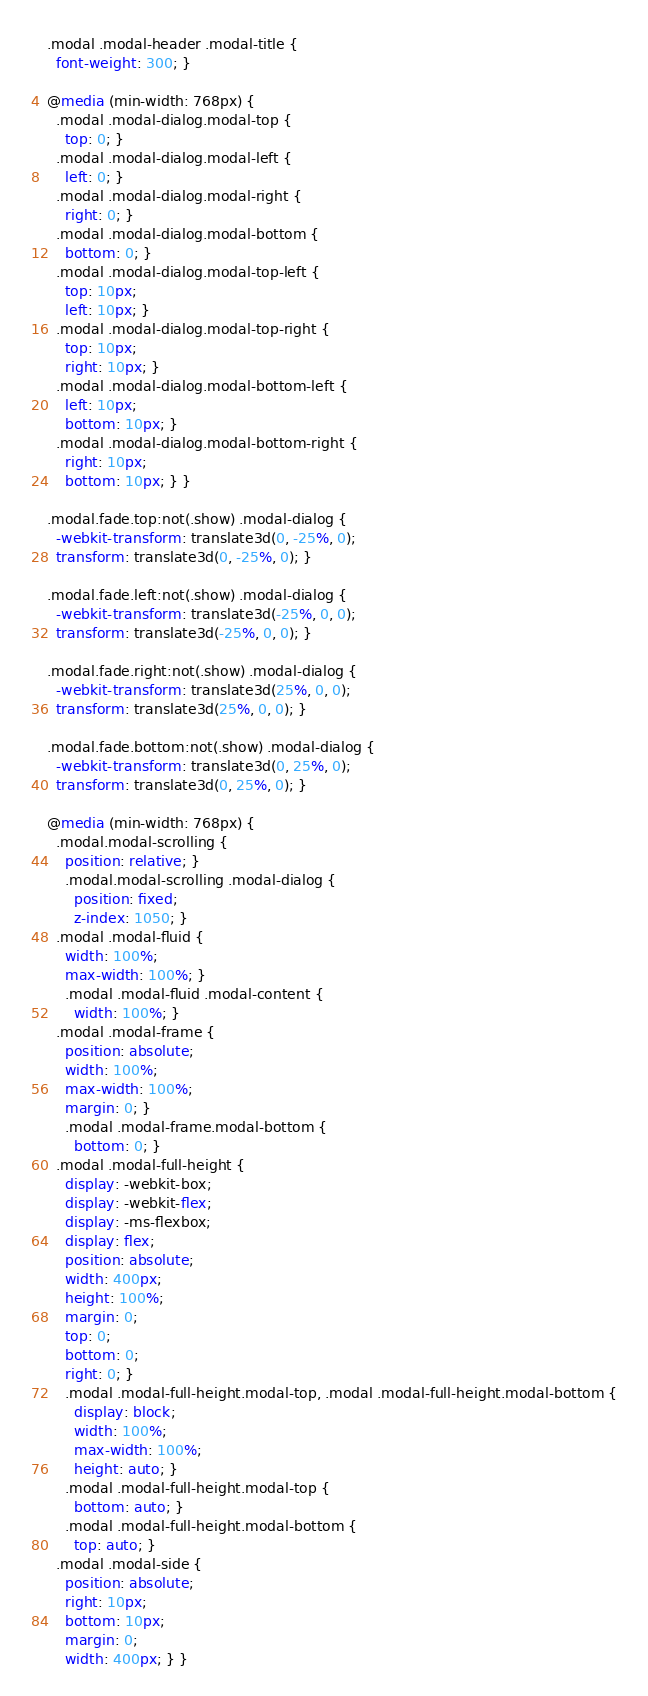Convert code to text. <code><loc_0><loc_0><loc_500><loc_500><_CSS_>
.modal .modal-header .modal-title {
  font-weight: 300; }

@media (min-width: 768px) {
  .modal .modal-dialog.modal-top {
    top: 0; }
  .modal .modal-dialog.modal-left {
    left: 0; }
  .modal .modal-dialog.modal-right {
    right: 0; }
  .modal .modal-dialog.modal-bottom {
    bottom: 0; }
  .modal .modal-dialog.modal-top-left {
    top: 10px;
    left: 10px; }
  .modal .modal-dialog.modal-top-right {
    top: 10px;
    right: 10px; }
  .modal .modal-dialog.modal-bottom-left {
    left: 10px;
    bottom: 10px; }
  .modal .modal-dialog.modal-bottom-right {
    right: 10px;
    bottom: 10px; } }

.modal.fade.top:not(.show) .modal-dialog {
  -webkit-transform: translate3d(0, -25%, 0);
  transform: translate3d(0, -25%, 0); }

.modal.fade.left:not(.show) .modal-dialog {
  -webkit-transform: translate3d(-25%, 0, 0);
  transform: translate3d(-25%, 0, 0); }

.modal.fade.right:not(.show) .modal-dialog {
  -webkit-transform: translate3d(25%, 0, 0);
  transform: translate3d(25%, 0, 0); }

.modal.fade.bottom:not(.show) .modal-dialog {
  -webkit-transform: translate3d(0, 25%, 0);
  transform: translate3d(0, 25%, 0); }

@media (min-width: 768px) {
  .modal.modal-scrolling {
    position: relative; }
    .modal.modal-scrolling .modal-dialog {
      position: fixed;
      z-index: 1050; }
  .modal .modal-fluid {
    width: 100%;
    max-width: 100%; }
    .modal .modal-fluid .modal-content {
      width: 100%; }
  .modal .modal-frame {
    position: absolute;
    width: 100%;
    max-width: 100%;
    margin: 0; }
    .modal .modal-frame.modal-bottom {
      bottom: 0; }
  .modal .modal-full-height {
    display: -webkit-box;
    display: -webkit-flex;
    display: -ms-flexbox;
    display: flex;
    position: absolute;
    width: 400px;
    height: 100%;
    margin: 0;
    top: 0;
    bottom: 0;
    right: 0; }
    .modal .modal-full-height.modal-top, .modal .modal-full-height.modal-bottom {
      display: block;
      width: 100%;
      max-width: 100%;
      height: auto; }
    .modal .modal-full-height.modal-top {
      bottom: auto; }
    .modal .modal-full-height.modal-bottom {
      top: auto; }
  .modal .modal-side {
    position: absolute;
    right: 10px;
    bottom: 10px;
    margin: 0;
    width: 400px; } }
</code> 